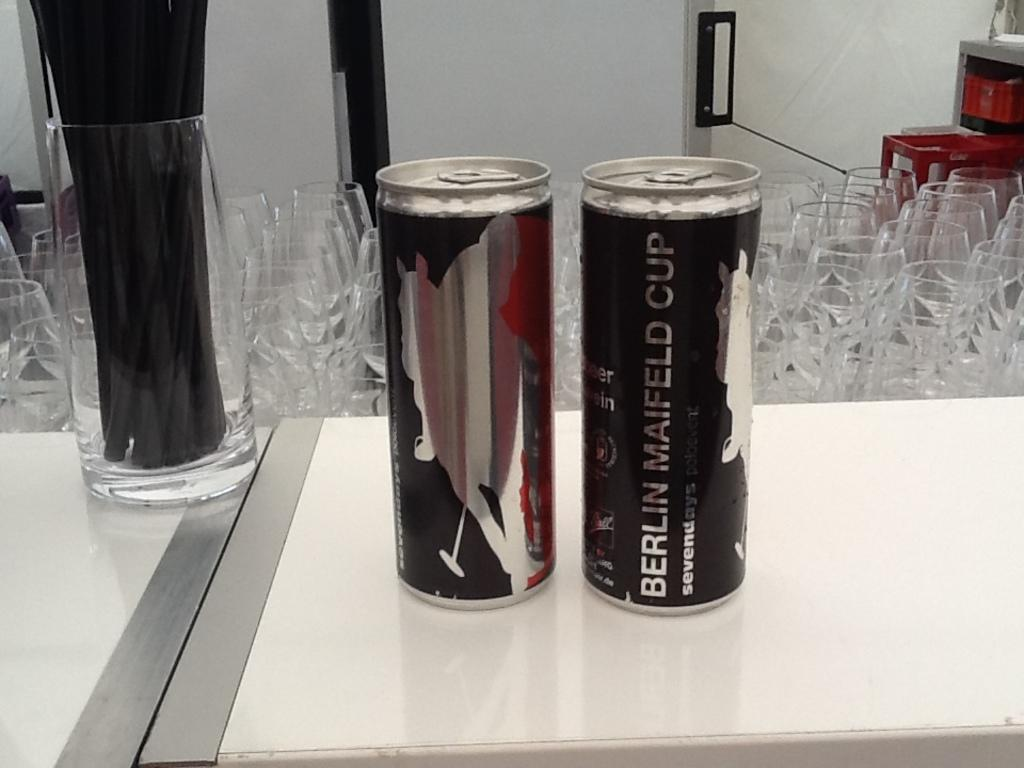What is inside the glass that is visible in the image? There are objects inside the glass in the image. Where is the glass located in the image? The glass is on a table in the image. What else can be seen in the background of the image? There are glasses and a white object that looks like a door in the background of the image. What type of flesh can be seen hanging from the door in the image? There is no flesh or door present in the image; it only features a glass with objects inside it and other glasses in the background. 